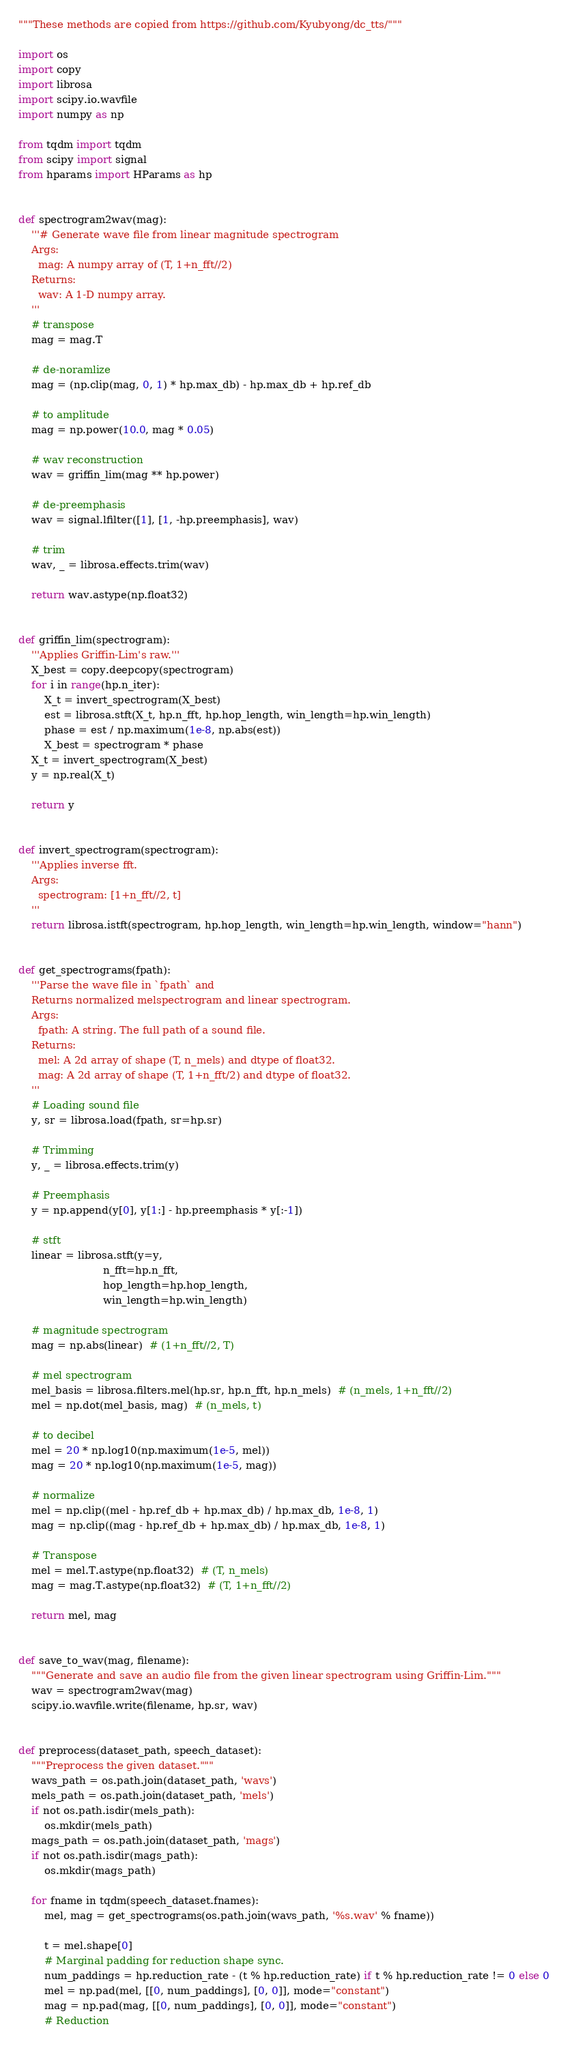<code> <loc_0><loc_0><loc_500><loc_500><_Python_>"""These methods are copied from https://github.com/Kyubyong/dc_tts/"""

import os
import copy
import librosa
import scipy.io.wavfile
import numpy as np

from tqdm import tqdm
from scipy import signal
from hparams import HParams as hp


def spectrogram2wav(mag):
    '''# Generate wave file from linear magnitude spectrogram
    Args:
      mag: A numpy array of (T, 1+n_fft//2)
    Returns:
      wav: A 1-D numpy array.
    '''
    # transpose
    mag = mag.T

    # de-noramlize
    mag = (np.clip(mag, 0, 1) * hp.max_db) - hp.max_db + hp.ref_db

    # to amplitude
    mag = np.power(10.0, mag * 0.05)

    # wav reconstruction
    wav = griffin_lim(mag ** hp.power)

    # de-preemphasis
    wav = signal.lfilter([1], [1, -hp.preemphasis], wav)

    # trim
    wav, _ = librosa.effects.trim(wav)

    return wav.astype(np.float32)


def griffin_lim(spectrogram):
    '''Applies Griffin-Lim's raw.'''
    X_best = copy.deepcopy(spectrogram)
    for i in range(hp.n_iter):
        X_t = invert_spectrogram(X_best)
        est = librosa.stft(X_t, hp.n_fft, hp.hop_length, win_length=hp.win_length)
        phase = est / np.maximum(1e-8, np.abs(est))
        X_best = spectrogram * phase
    X_t = invert_spectrogram(X_best)
    y = np.real(X_t)

    return y


def invert_spectrogram(spectrogram):
    '''Applies inverse fft.
    Args:
      spectrogram: [1+n_fft//2, t]
    '''
    return librosa.istft(spectrogram, hp.hop_length, win_length=hp.win_length, window="hann")


def get_spectrograms(fpath):
    '''Parse the wave file in `fpath` and
    Returns normalized melspectrogram and linear spectrogram.
    Args:
      fpath: A string. The full path of a sound file.
    Returns:
      mel: A 2d array of shape (T, n_mels) and dtype of float32.
      mag: A 2d array of shape (T, 1+n_fft/2) and dtype of float32.
    '''
    # Loading sound file
    y, sr = librosa.load(fpath, sr=hp.sr)

    # Trimming
    y, _ = librosa.effects.trim(y)

    # Preemphasis
    y = np.append(y[0], y[1:] - hp.preemphasis * y[:-1])

    # stft
    linear = librosa.stft(y=y,
                          n_fft=hp.n_fft,
                          hop_length=hp.hop_length,
                          win_length=hp.win_length)

    # magnitude spectrogram
    mag = np.abs(linear)  # (1+n_fft//2, T)

    # mel spectrogram
    mel_basis = librosa.filters.mel(hp.sr, hp.n_fft, hp.n_mels)  # (n_mels, 1+n_fft//2)
    mel = np.dot(mel_basis, mag)  # (n_mels, t)

    # to decibel
    mel = 20 * np.log10(np.maximum(1e-5, mel))
    mag = 20 * np.log10(np.maximum(1e-5, mag))

    # normalize
    mel = np.clip((mel - hp.ref_db + hp.max_db) / hp.max_db, 1e-8, 1)
    mag = np.clip((mag - hp.ref_db + hp.max_db) / hp.max_db, 1e-8, 1)

    # Transpose
    mel = mel.T.astype(np.float32)  # (T, n_mels)
    mag = mag.T.astype(np.float32)  # (T, 1+n_fft//2)

    return mel, mag


def save_to_wav(mag, filename):
    """Generate and save an audio file from the given linear spectrogram using Griffin-Lim."""
    wav = spectrogram2wav(mag)
    scipy.io.wavfile.write(filename, hp.sr, wav)


def preprocess(dataset_path, speech_dataset):
    """Preprocess the given dataset."""
    wavs_path = os.path.join(dataset_path, 'wavs')
    mels_path = os.path.join(dataset_path, 'mels')
    if not os.path.isdir(mels_path):
        os.mkdir(mels_path)
    mags_path = os.path.join(dataset_path, 'mags')
    if not os.path.isdir(mags_path):
        os.mkdir(mags_path)

    for fname in tqdm(speech_dataset.fnames):
        mel, mag = get_spectrograms(os.path.join(wavs_path, '%s.wav' % fname))

        t = mel.shape[0]
        # Marginal padding for reduction shape sync.
        num_paddings = hp.reduction_rate - (t % hp.reduction_rate) if t % hp.reduction_rate != 0 else 0
        mel = np.pad(mel, [[0, num_paddings], [0, 0]], mode="constant")
        mag = np.pad(mag, [[0, num_paddings], [0, 0]], mode="constant")
        # Reduction</code> 